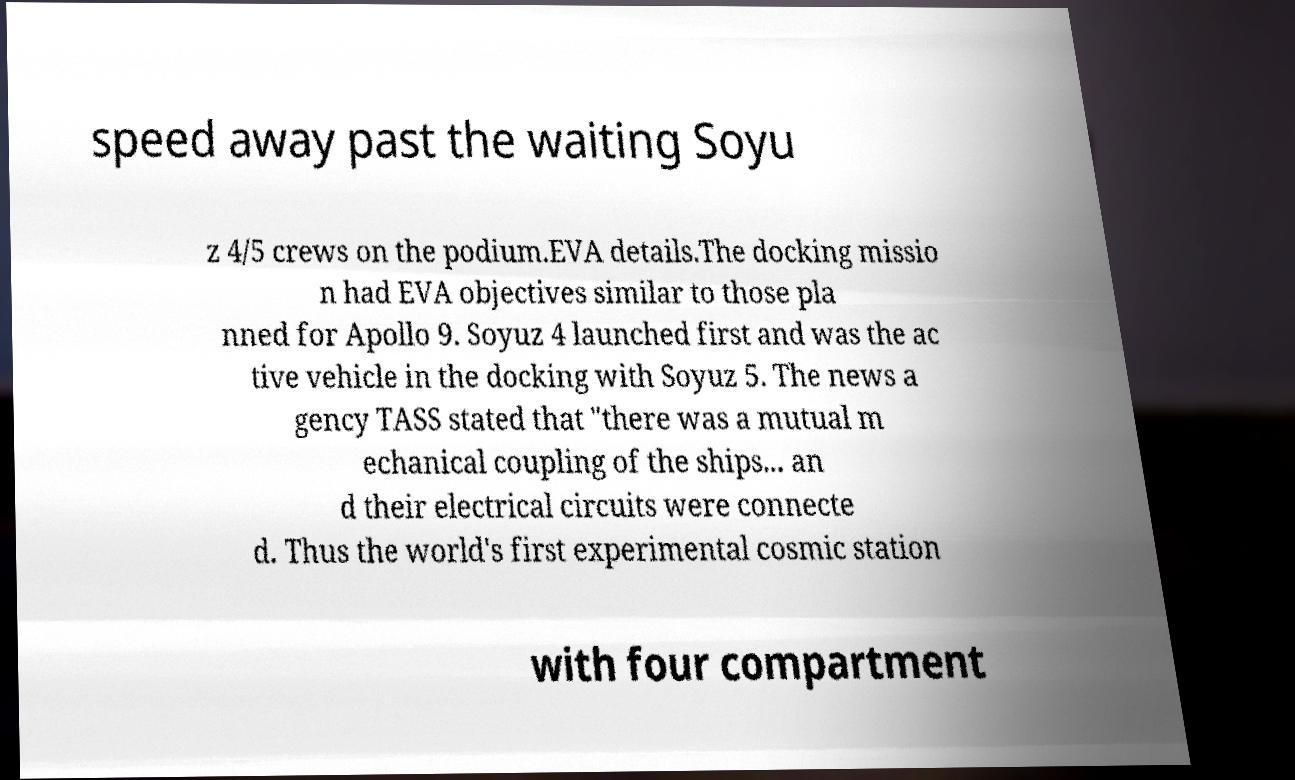Please read and relay the text visible in this image. What does it say? speed away past the waiting Soyu z 4/5 crews on the podium.EVA details.The docking missio n had EVA objectives similar to those pla nned for Apollo 9. Soyuz 4 launched first and was the ac tive vehicle in the docking with Soyuz 5. The news a gency TASS stated that "there was a mutual m echanical coupling of the ships... an d their electrical circuits were connecte d. Thus the world's first experimental cosmic station with four compartment 